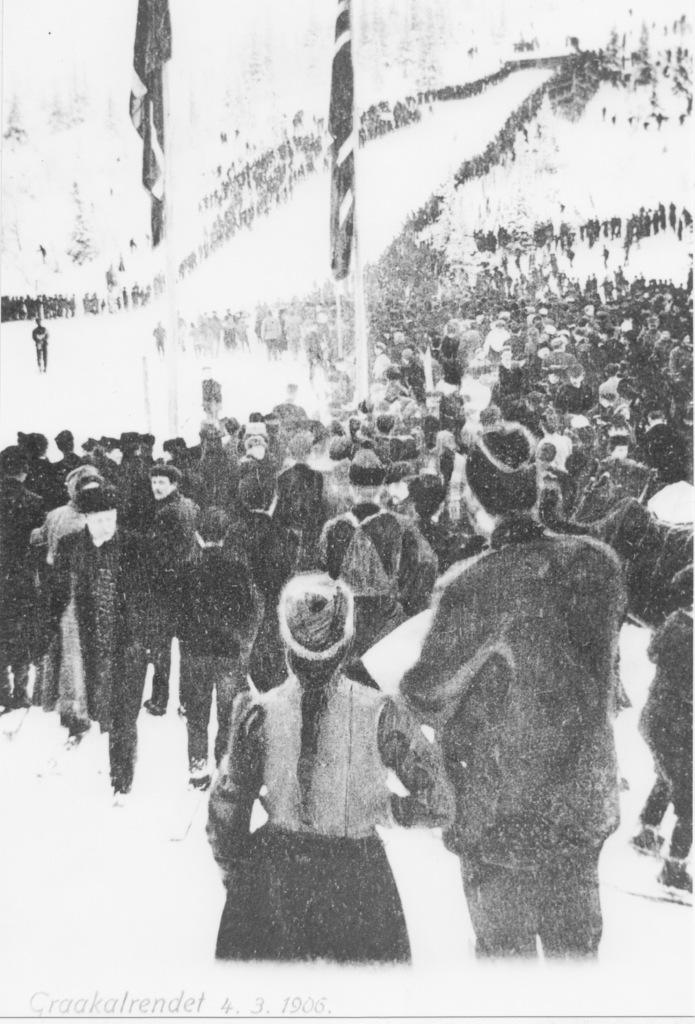What can be seen in the image? There are people standing in the image. What else is present in the image besides people? There are two flags on poles in the image. Can you describe the people in the image? There are both men and women in the image. What is the color scheme of the image? The image is black and white. What is the opinion of the creature in the image? There is no creature present in the image, so it is not possible to determine its opinion. 